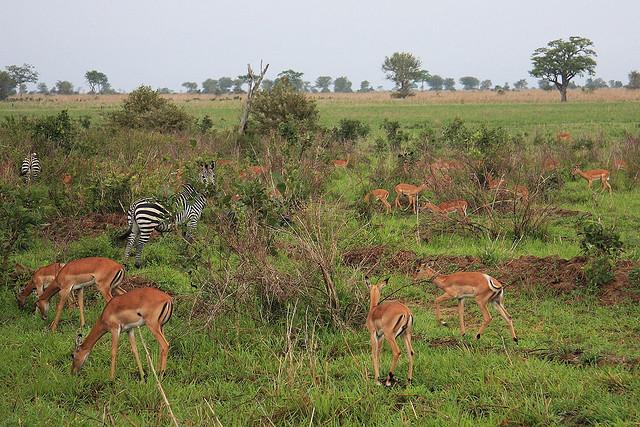How many different animals is in the photo?
Concise answer only. 2. What is the animals in brown?
Concise answer only. Deer. How many deer are on the field?
Quick response, please. 18. What color are the animals in the photo?
Keep it brief. Brown. 